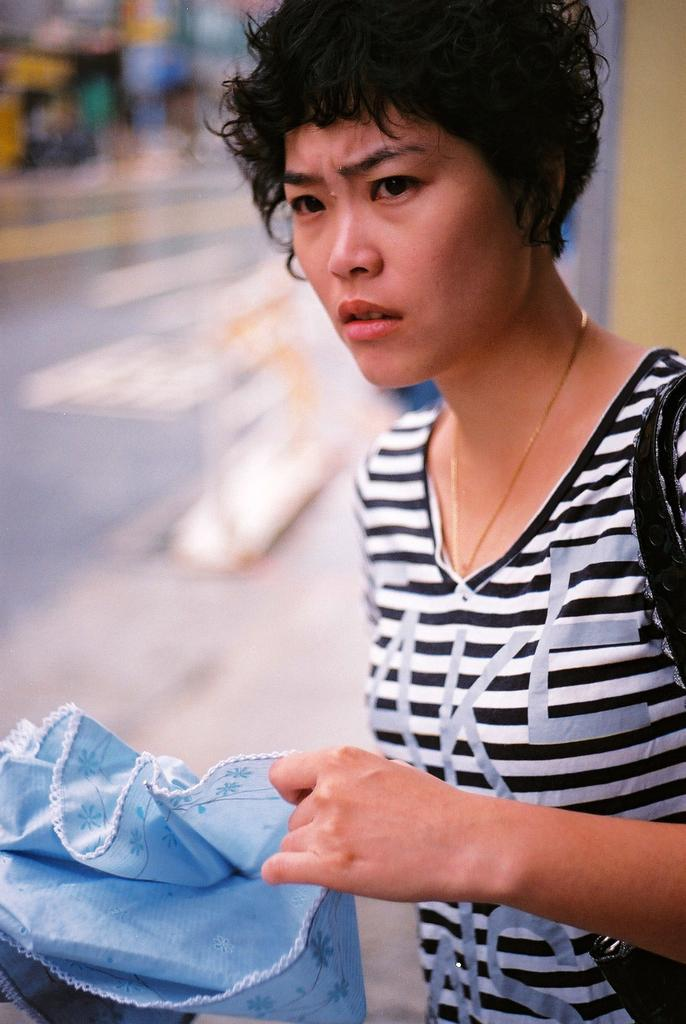What is the main subject on the right side of the image? There is a woman on the right side of the image. What is the woman wearing on her upper body? The woman is wearing a t-shirt. What accessory is the woman carrying in the image? The woman is wearing a handbag. What is the woman holding in her hand? The woman is holding a cloth. 3. What can be observed about the background of the image? What organization is the woman starting in the image? There is no indication in the image that the woman is starting or joining any organization. 